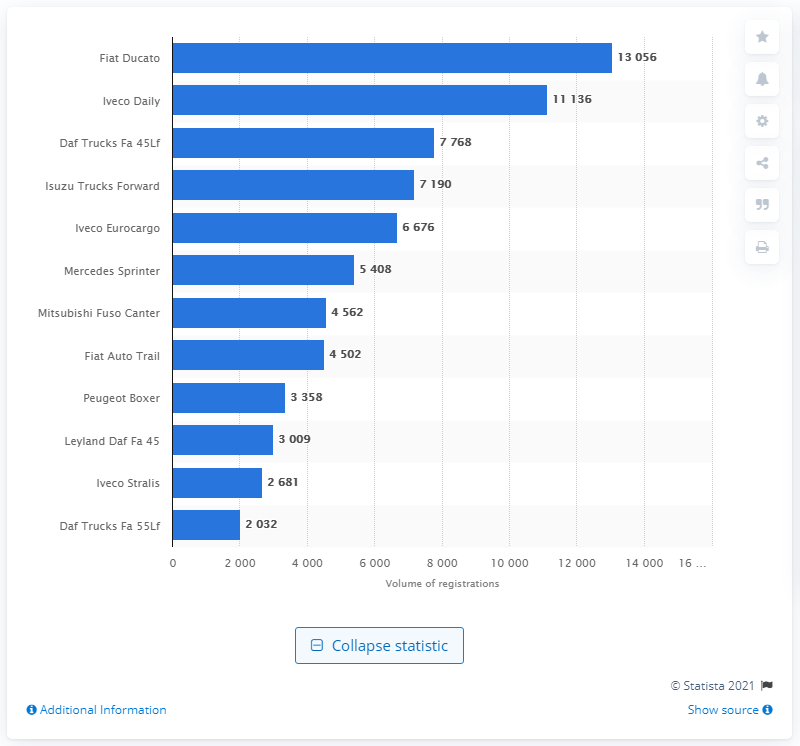Identify some key points in this picture. In the third quarter of 2020, the Fiat Ducato was the most common medium and heavy commercial vehicle on the roads in the United Kingdom. 